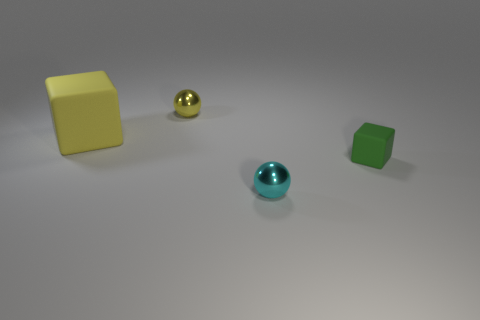Add 1 yellow cubes. How many objects exist? 5 Add 2 tiny yellow objects. How many tiny yellow objects are left? 3 Add 3 red cubes. How many red cubes exist? 3 Subtract 0 red balls. How many objects are left? 4 Subtract all yellow rubber blocks. Subtract all yellow blocks. How many objects are left? 2 